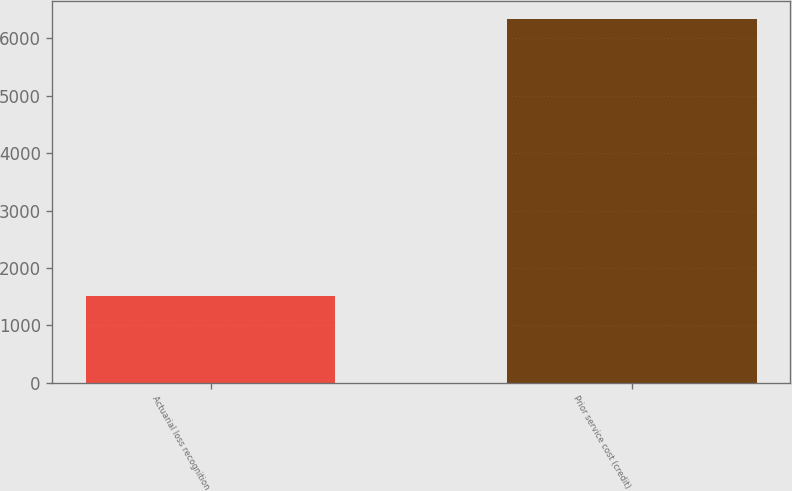Convert chart. <chart><loc_0><loc_0><loc_500><loc_500><bar_chart><fcel>Actuarial loss recognition<fcel>Prior service cost (credit)<nl><fcel>1513<fcel>6334<nl></chart> 